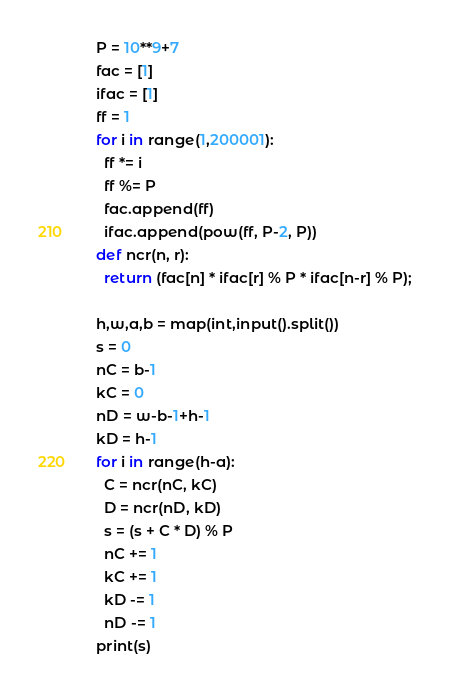<code> <loc_0><loc_0><loc_500><loc_500><_Python_>P = 10**9+7
fac = [1]
ifac = [1]
ff = 1
for i in range(1,200001):
  ff *= i
  ff %= P
  fac.append(ff)
  ifac.append(pow(ff, P-2, P))
def ncr(n, r): 
  return (fac[n] * ifac[r] % P * ifac[n-r] % P);

h,w,a,b = map(int,input().split())
s = 0
nC = b-1
kC = 0
nD = w-b-1+h-1
kD = h-1
for i in range(h-a):
  C = ncr(nC, kC)
  D = ncr(nD, kD)
  s = (s + C * D) % P
  nC += 1
  kC += 1
  kD -= 1
  nD -= 1
print(s)
</code> 